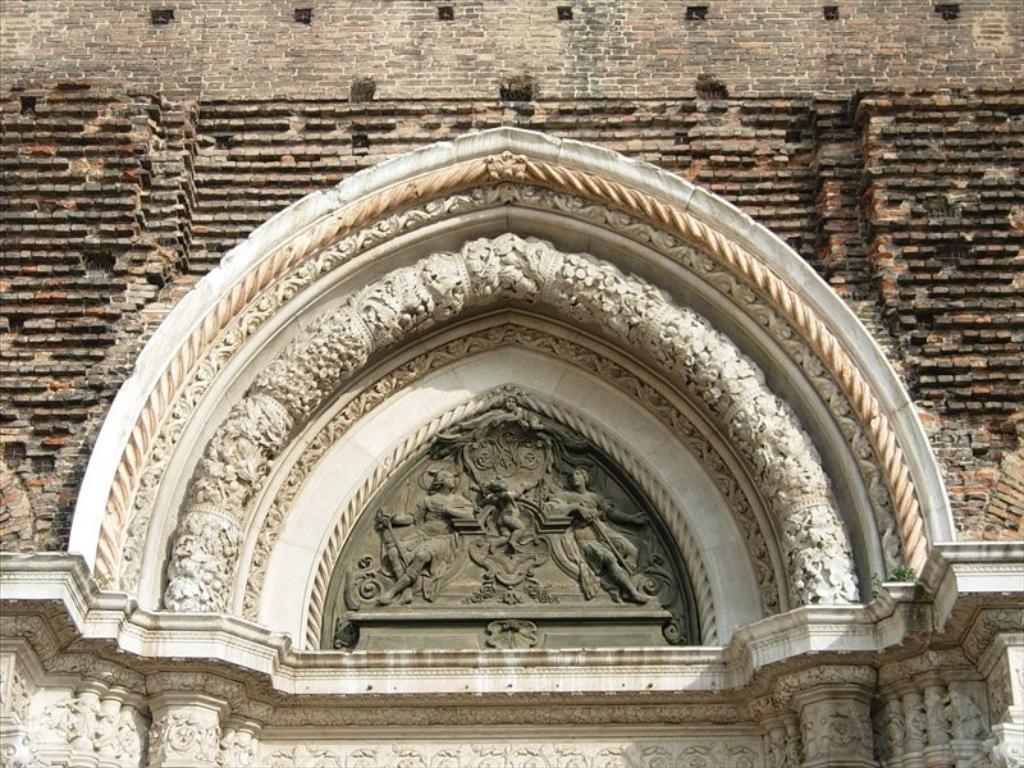Can you describe this image briefly? In this image I can see a part of a building. Here I can see the carvings on the wall. 